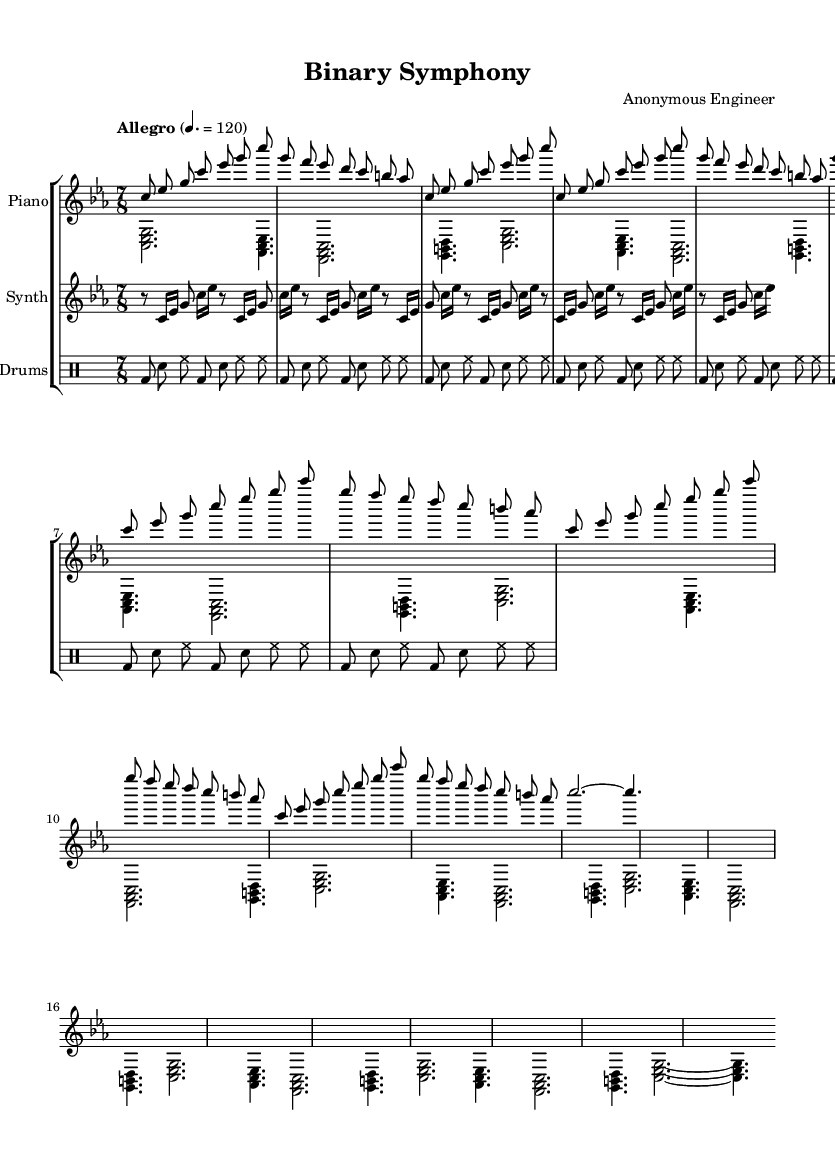what is the key signature of this music? The key signature is indicated by the number of flats or sharps at the beginning of the staff. In this case, the absence of sharps or flats suggests that the key signature is C minor, which traditionally has three flats but is not explicitly shown here. So we deduce that it's C minor based on further context in the piece.
Answer: C minor what is the time signature of this music? The time signature is shown at the beginning of the music piece, represented as a fraction. In this instance, the bottom number indicates eighth notes as the beat unit, and the top number indicates there are seven beats per measure. Therefore, the time signature is 7/8.
Answer: 7/8 what is the tempo marking in this piece? The tempo is usually indicated right after the global settings in the header. Here, the marking "Allegro" indicates a fast tempo, specifically noted as a metronome marking of quarter note equals 120 beats per minute.
Answer: Allegro how many times is Theme A repeated? The number of repetitions of themes is noted in the respective sections. Theme A appears explicitly marked with a repeat indication, and it is repeated 2 times consecutively.
Answer: 2 how does the synthesizer part relate to the rhythmic structure in the piece? The synthesizer part consists of a repeating pattern that aligns with the overall 7/8 time signature, contributing to the drive of the piece. It features a combination of sustained notes and rests that interweave rhythmically with the drum patterns, creating a layered texture that highlights the complex meter. This shows how electronic elements can interact with classical forms.
Answer: It complements the rhythm what types of instruments are featured in this composition? The score indicates different staff groups, each associated with specific instruments. There are references to a piano (for both left and right parts), a synthesizer, and drums, visibly designated by their respective labels within the score format. This mix showcases the integration of traditional and contemporary instruments.
Answer: Piano, Synth, Drums what is the form of the piece based on the provided structure? The piece follows a structured form by identifying sections labeled as Introduction, Theme A, Theme B, Development, Recapitulation, and Coda. This demonstrates a classical sonata-allegro form infused with contemporary elements like repetition and electronic integration, providing insight into its formal design.
Answer: Sonata-allegro form 